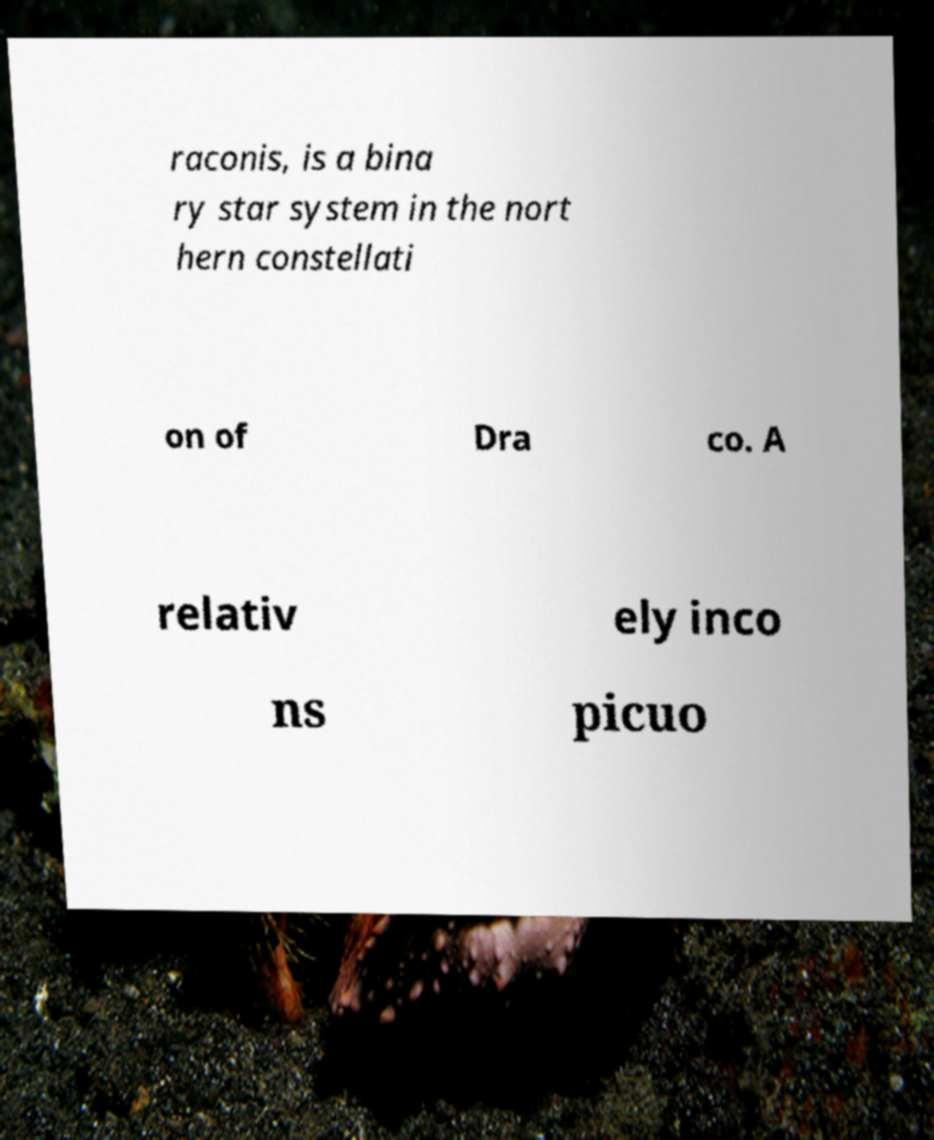Please identify and transcribe the text found in this image. raconis, is a bina ry star system in the nort hern constellati on of Dra co. A relativ ely inco ns picuo 